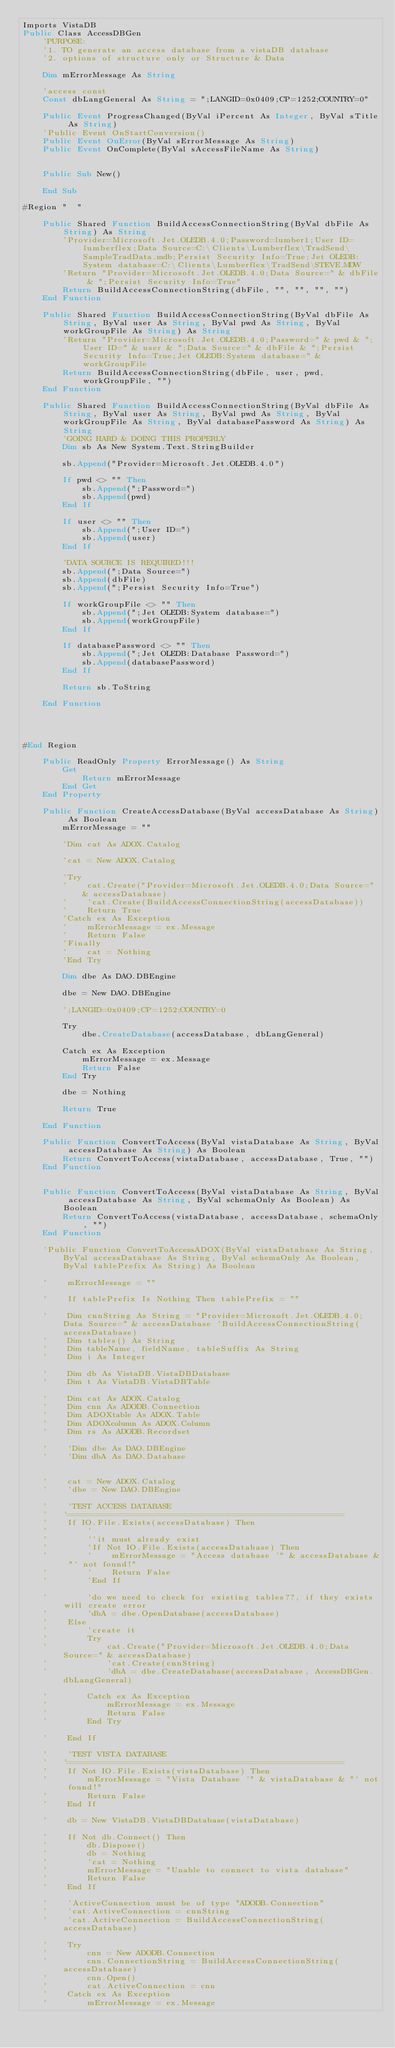Convert code to text. <code><loc_0><loc_0><loc_500><loc_500><_VisualBasic_>Imports VistaDB
Public Class AccessDBGen
    'PURPOSE:
    '1. TO generate an access database from a vistaDB database
    '2. options of structure only or Structure & Data

    Dim mErrorMessage As String

    'access const
    Const dbLangGeneral As String = ";LANGID=0x0409;CP=1252;COUNTRY=0"

    Public Event ProgressChanged(ByVal iPercent As Integer, ByVal sTitle As String)
    'Public Event OnStartConversion()
    Public Event OnError(ByVal sErrorMessage As String)
    Public Event OnComplete(ByVal sAccessFileName As String)


    Public Sub New()

    End Sub

#Region "  "

    Public Shared Function BuildAccessConnectionString(ByVal dbFile As String) As String
        'Provider=Microsoft.Jet.OLEDB.4.0;Password=lumber1;User ID=lumberflex;Data Source=C:\Clients\Lumberflex\TradSend\SampleTradData.mdb;Persist Security Info=True;Jet OLEDB:System database=C:\Clients\Lumberflex\TradSend\STEVE.MDW
        'Return "Provider=Microsoft.Jet.OLEDB.4.0;Data Source=" & dbFile & ";Persist Security Info=True"
        Return BuildAccessConnectionString(dbFile, "", "", "", "")
    End Function

    Public Shared Function BuildAccessConnectionString(ByVal dbFile As String, ByVal user As String, ByVal pwd As String, ByVal workGroupFile As String) As String
        'Return "Provider=Microsoft.Jet.OLEDB.4.0;Password=" & pwd & ";User ID=" & user & ";Data Source=" & dbFile & ";Persist Security Info=True;Jet OLEDB:System database=" & workGroupFile
        Return BuildAccessConnectionString(dbFile, user, pwd, workGroupFile, "")
    End Function

    Public Shared Function BuildAccessConnectionString(ByVal dbFile As String, ByVal user As String, ByVal pwd As String, ByVal workGroupFile As String, ByVal databasePassword As String) As String
        'GOING HARD & DOING THIS PROPERLY
        Dim sb As New System.Text.StringBuilder

        sb.Append("Provider=Microsoft.Jet.OLEDB.4.0")

        If pwd <> "" Then
            sb.Append(";Password=")
            sb.Append(pwd)
        End If

        If user <> "" Then
            sb.Append(";User ID=")
            sb.Append(user)
        End If

        'DATA SOURCE IS REQUIRED!!!
        sb.Append(";Data Source=")
        sb.Append(dbFile)
        sb.Append(";Persist Security Info=True")

        If workGroupFile <> "" Then
            sb.Append(";Jet OLEDB:System database=")
            sb.Append(workGroupFile)
        End If

        If databasePassword <> "" Then
            sb.Append(";Jet OLEDB:Database Password=")
            sb.Append(databasePassword)
        End If

        Return sb.ToString

    End Function




#End Region

    Public ReadOnly Property ErrorMessage() As String
        Get
            Return mErrorMessage
        End Get
    End Property

    Public Function CreateAccessDatabase(ByVal accessDatabase As String) As Boolean
        mErrorMessage = ""

        'Dim cat As ADOX.Catalog

        'cat = New ADOX.Catalog

        'Try
        '    cat.Create("Provider=Microsoft.Jet.OLEDB.4.0;Data Source=" & accessDatabase)
        '    'cat.Create(BuildAccessConnectionString(accessDatabase))
        '    Return True
        'Catch ex As Exception
        '    mErrorMessage = ex.Message
        '    Return False
        'Finally
        '    cat = Nothing
        'End Try

        Dim dbe As DAO.DBEngine

        dbe = New DAO.DBEngine

        ';LANGID=0x0409;CP=1252;COUNTRY=0

        Try
            dbe.CreateDatabase(accessDatabase, dbLangGeneral)

        Catch ex As Exception
            mErrorMessage = ex.Message
            Return False
        End Try

        dbe = Nothing

        Return True

    End Function

    Public Function ConvertToAccess(ByVal vistaDatabase As String, ByVal accessDatabase As String) As Boolean
        Return ConvertToAccess(vistaDatabase, accessDatabase, True, "")
    End Function


	Public Function ConvertToAccess(ByVal vistaDatabase As String, ByVal accessDatabase As String, ByVal schemaOnly As Boolean) As Boolean
		Return ConvertToAccess(vistaDatabase, accessDatabase, schemaOnly, "")
	End Function

    'Public Function ConvertToAccessADOX(ByVal vistaDatabase As String, ByVal accessDatabase As String, ByVal schemaOnly As Boolean, ByVal tablePrefix As String) As Boolean

    '    mErrorMessage = ""

    '    If tablePrefix Is Nothing Then tablePrefix = ""

    '    Dim cnnString As String = "Provider=Microsoft.Jet.OLEDB.4.0;Data Source=" & accessDatabase 'BuildAccessConnectionString(accessDatabase)
    '    Dim tables() As String
    '    Dim tableName, fieldName, tableSuffix As String
    '    Dim i As Integer

    '    Dim db As VistaDB.VistaDBDatabase
    '    Dim t As VistaDB.VistaDBTable

    '    Dim cat As ADOX.Catalog
    '    Dim cnn As ADODB.Connection
    '    Dim ADOXtable As ADOX.Table
    '    Dim ADOXcolumn As ADOX.Column
    '    Dim rs As ADODB.Recordset

    '    'Dim dbe As DAO.DBEngine
    '    'Dim dbA As DAO.Database


    '    cat = New ADOX.Catalog
    '    'dbe = New DAO.DBEngine

    '    'TEST ACCESS DATABASE
    '    '=======================================================
    '    If IO.File.Exists(accessDatabase) Then
    '        '
    '        ''it must already exist
    '        'If Not IO.File.Exists(accessDatabase) Then
    '        '    mErrorMessage = "Access database '" & accessDatabase & "' not found!"
    '        '    Return False
    '        'End If

    '        'do we need to check for existing tables??, if they exists will create error
    '        'dbA = dbe.OpenDatabase(accessDatabase)
    '    Else
    '        'create it
    '        Try
    '            cat.Create("Provider=Microsoft.Jet.OLEDB.4.0;Data Source=" & accessDatabase)
    '            'cat.Create(cnnString)
    '            'dbA = dbe.CreateDatabase(accessDatabase, AccessDBGen.dbLangGeneral)

    '        Catch ex As Exception
    '            mErrorMessage = ex.Message
    '            Return False
    '        End Try

    '    End If

    '    'TEST VISTA DATABASE
    '    '=======================================================
    '    If Not IO.File.Exists(vistaDatabase) Then
    '        mErrorMessage = "Vista Database '" & vistaDatabase & "' not found!"
    '        Return False
    '    End If

    '    db = New VistaDB.VistaDBDatabase(vistaDatabase)

    '    If Not db.Connect() Then
    '        db.Dispose()
    '        db = Nothing
    '        'cat = Nothing
    '        mErrorMessage = "Unable to connect to vista database"
    '        Return False
    '    End If

    '    'ActiveConnection must be of type "ADODB.Connection"
    '    'cat.ActiveConnection = cnnString
    '    'cat.ActiveConnection = BuildAccessConnectionString(accessDatabase)

    '    Try
    '        cnn = New ADODB.Connection
    '        cnn.ConnectionString = BuildAccessConnectionString(accessDatabase)
    '        cnn.Open()
    '        cat.ActiveConnection = cnn
    '    Catch ex As Exception
    '        mErrorMessage = ex.Message</code> 